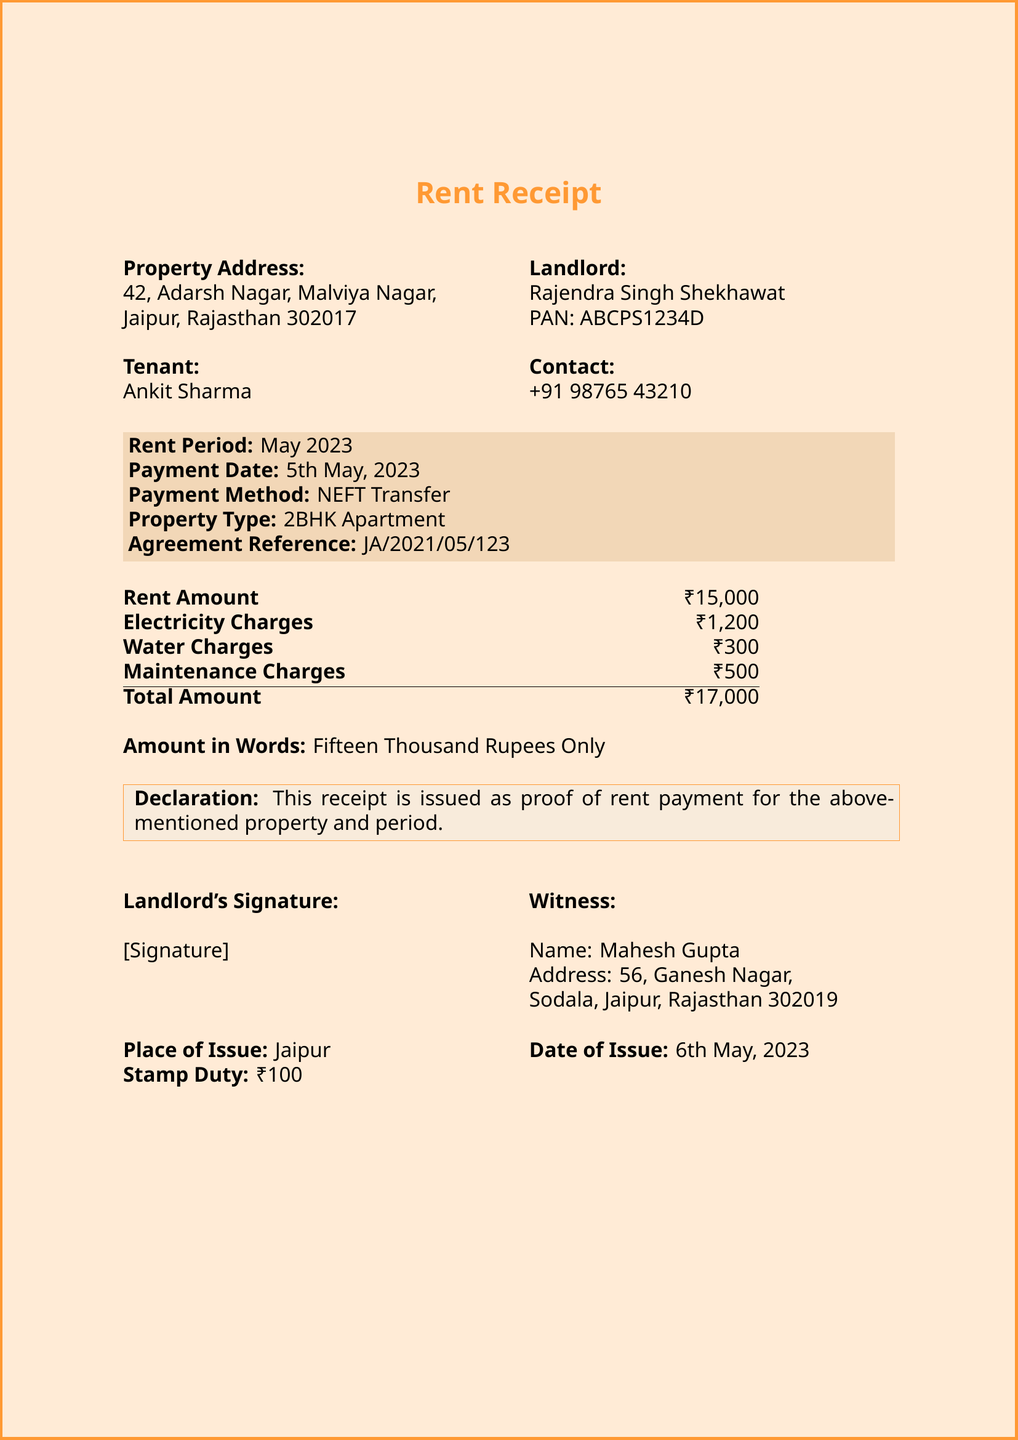What is the property address? The property address is listed clearly in the document under the property details section.
Answer: 42, Adarsh Nagar, Malviya Nagar, Jaipur, Rajasthan 302017 Who is the landlord? The landlord's name is mentioned at the beginning of the document.
Answer: Rajendra Singh Shekhawat What is the total amount paid for rent? The total amount is calculated in the payment details section of the receipt.
Answer: ₹17,000 What is the payment method used? The payment method is specified in the payment details section.
Answer: NEFT Transfer What is the rent period? The rent period is stated in the designated section of the receipt.
Answer: May 2023 How much is the electricity charge? The document lists the electricity charges specifically in the payment breakdown.
Answer: ₹1,200 What is the amount in words? The amount in words is provided to clarify the total rent amount for the document's purpose.
Answer: Fifteen Thousand Rupees Only What is the date of issue? The date the receipt was issued is explicitly mentioned towards the end of the document.
Answer: 6th May, 2023 What is the witness name? The witness name is included in the signature section of the receipt.
Answer: Mahesh Gupta 